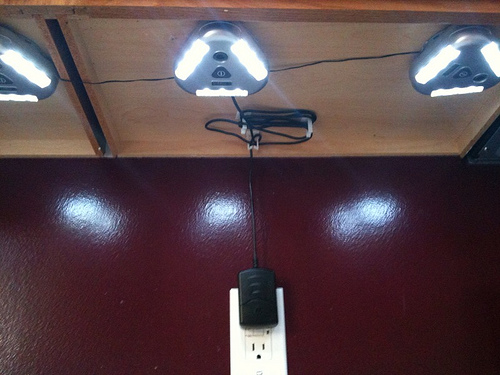<image>
Can you confirm if the wall plug is behind the wall? No. The wall plug is not behind the wall. From this viewpoint, the wall plug appears to be positioned elsewhere in the scene. 